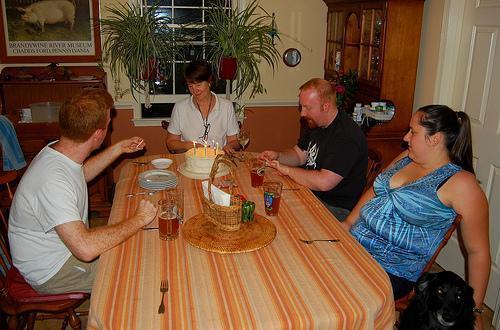How many dogs are there?
Give a very brief answer. 1. How many women are there?
Give a very brief answer. 2. 